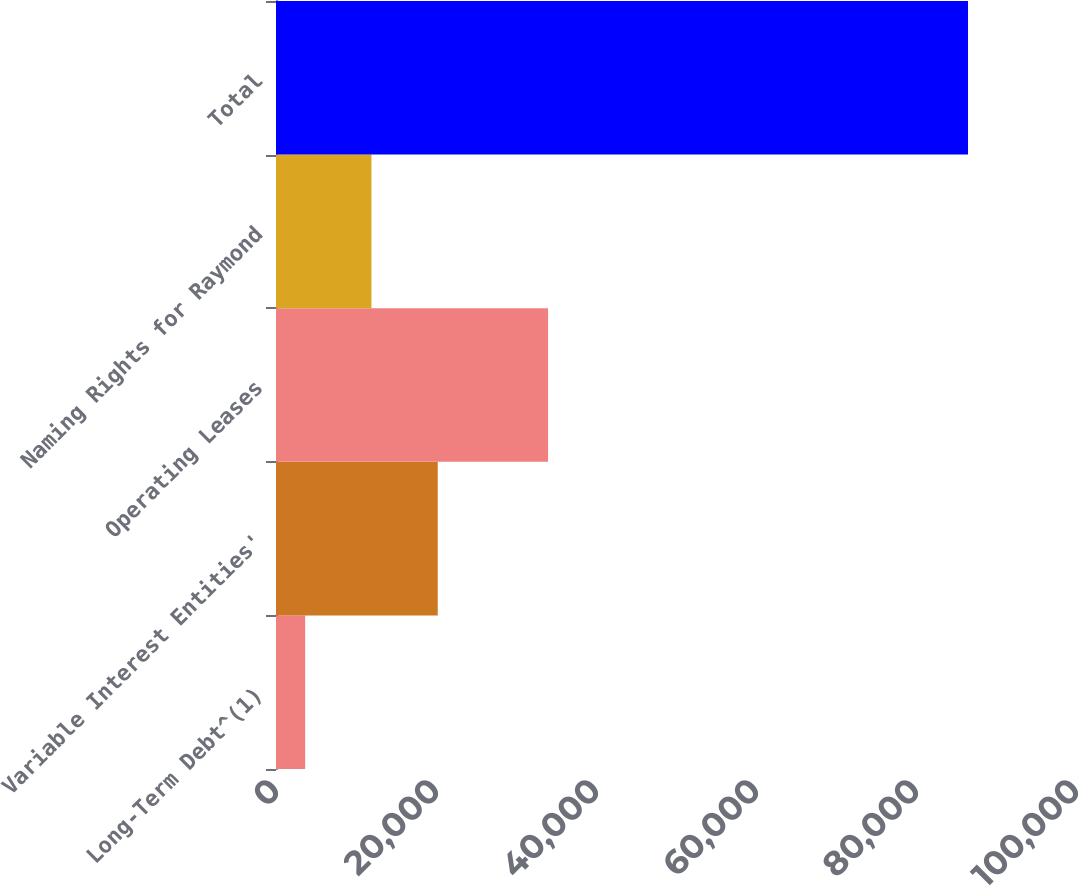<chart> <loc_0><loc_0><loc_500><loc_500><bar_chart><fcel>Long-Term Debt^(1)<fcel>Variable Interest Entities'<fcel>Operating Leases<fcel>Naming Rights for Raymond<fcel>Total<nl><fcel>3647<fcel>20218.2<fcel>34010<fcel>11932.6<fcel>86503<nl></chart> 